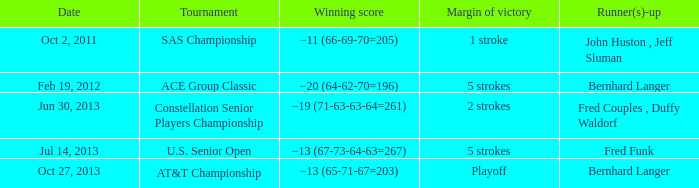Which Date has a Runner(s)-up of bernhard langer, and a Tournament of at&t championship? Oct 27, 2013. 